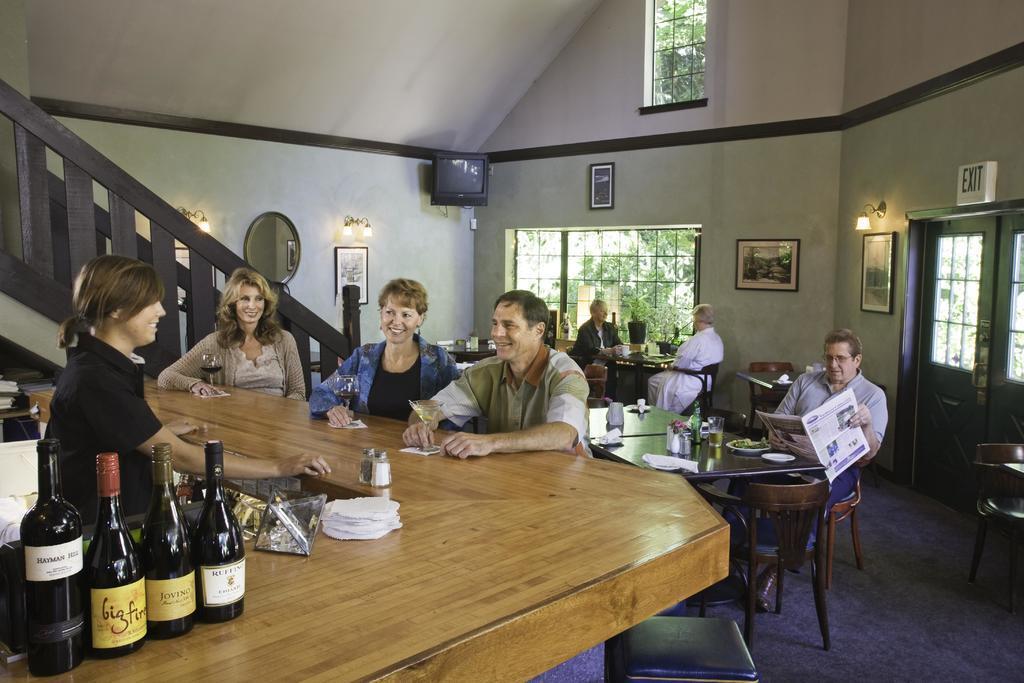Please provide a concise description of this image. In this image there are group of people sitting in chair and there is a table consists of wine bottles , tissues and in back ground there is television , frame , tree ,window, stair case , mirror. 